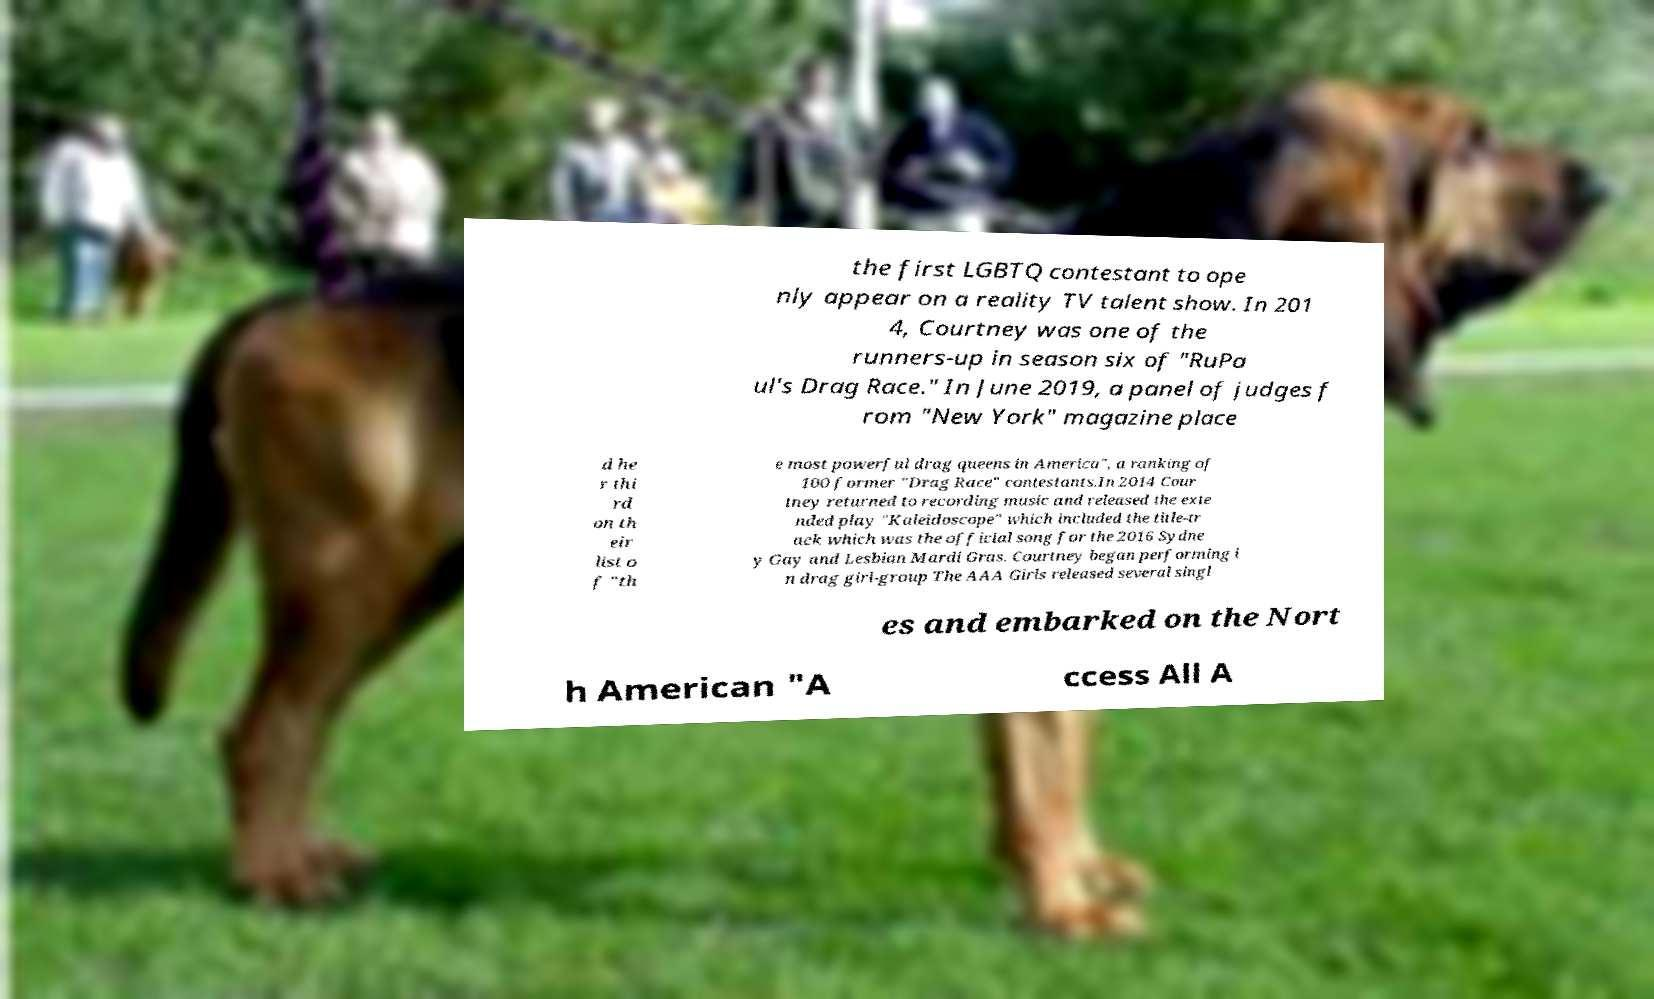Please read and relay the text visible in this image. What does it say? the first LGBTQ contestant to ope nly appear on a reality TV talent show. In 201 4, Courtney was one of the runners-up in season six of "RuPa ul's Drag Race." In June 2019, a panel of judges f rom "New York" magazine place d he r thi rd on th eir list o f "th e most powerful drag queens in America", a ranking of 100 former "Drag Race" contestants.In 2014 Cour tney returned to recording music and released the exte nded play "Kaleidoscope" which included the title-tr ack which was the official song for the 2016 Sydne y Gay and Lesbian Mardi Gras. Courtney began performing i n drag girl-group The AAA Girls released several singl es and embarked on the Nort h American "A ccess All A 